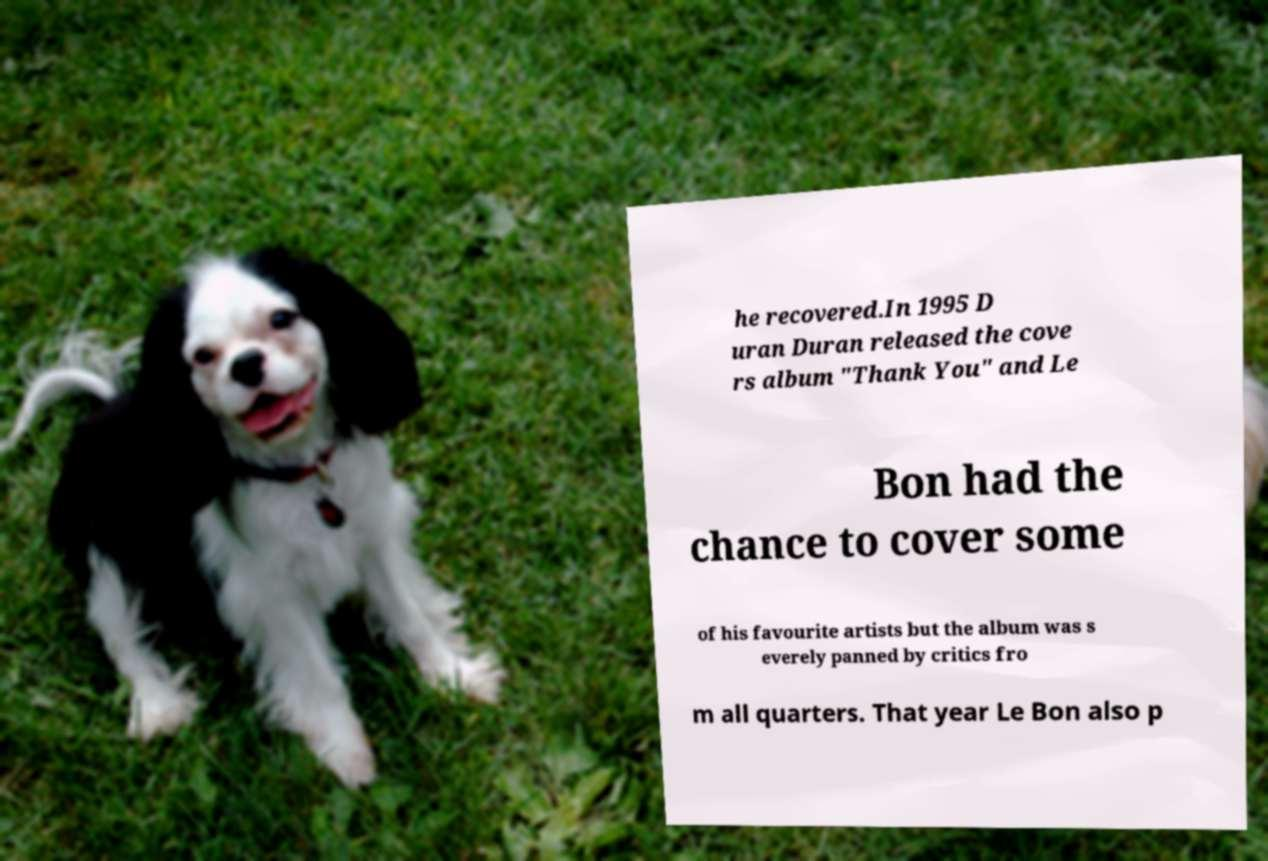Could you extract and type out the text from this image? he recovered.In 1995 D uran Duran released the cove rs album "Thank You" and Le Bon had the chance to cover some of his favourite artists but the album was s everely panned by critics fro m all quarters. That year Le Bon also p 